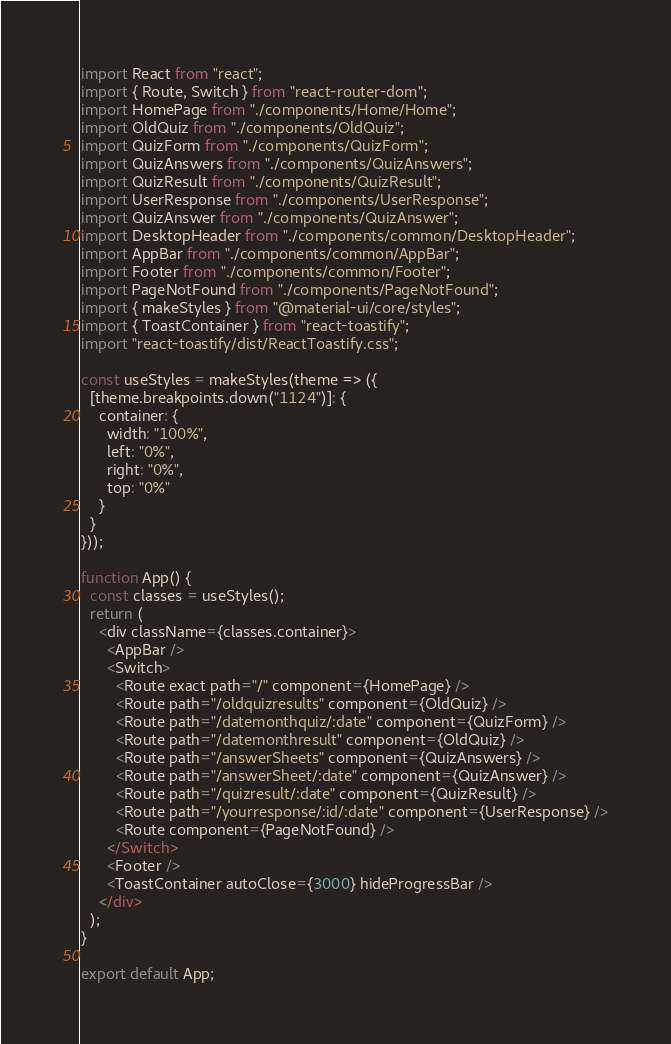<code> <loc_0><loc_0><loc_500><loc_500><_JavaScript_>import React from "react";
import { Route, Switch } from "react-router-dom";
import HomePage from "./components/Home/Home";
import OldQuiz from "./components/OldQuiz";
import QuizForm from "./components/QuizForm";
import QuizAnswers from "./components/QuizAnswers";
import QuizResult from "./components/QuizResult";
import UserResponse from "./components/UserResponse";
import QuizAnswer from "./components/QuizAnswer";
import DesktopHeader from "./components/common/DesktopHeader";
import AppBar from "./components/common/AppBar";
import Footer from "./components/common/Footer";
import PageNotFound from "./components/PageNotFound";
import { makeStyles } from "@material-ui/core/styles";
import { ToastContainer } from "react-toastify";
import "react-toastify/dist/ReactToastify.css";

const useStyles = makeStyles(theme => ({
  [theme.breakpoints.down("1124")]: {
    container: {
      width: "100%",
      left: "0%",
      right: "0%",
      top: "0%"
    }
  }
}));

function App() {
  const classes = useStyles();
  return (
    <div className={classes.container}>
      <AppBar />
      <Switch>
        <Route exact path="/" component={HomePage} />
        <Route path="/oldquizresults" component={OldQuiz} />
        <Route path="/datemonthquiz/:date" component={QuizForm} />
        <Route path="/datemonthresult" component={OldQuiz} />
        <Route path="/answerSheets" component={QuizAnswers} />
        <Route path="/answerSheet/:date" component={QuizAnswer} />
        <Route path="/quizresult/:date" component={QuizResult} />
        <Route path="/yourresponse/:id/:date" component={UserResponse} />
        <Route component={PageNotFound} />
      </Switch>
      <Footer />
      <ToastContainer autoClose={3000} hideProgressBar />
    </div>
  );
}

export default App;
</code> 